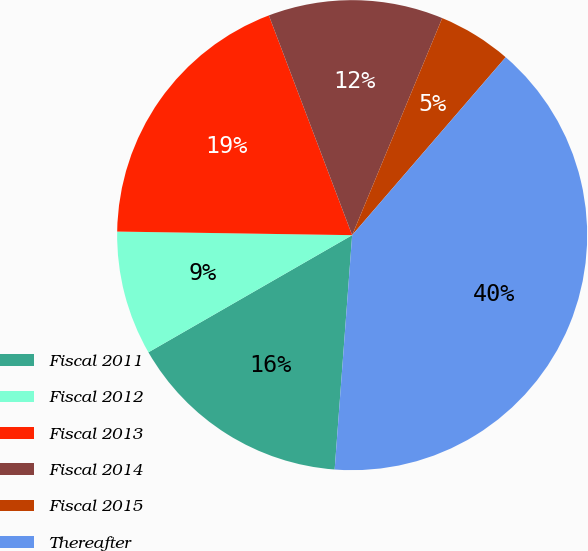Convert chart to OTSL. <chart><loc_0><loc_0><loc_500><loc_500><pie_chart><fcel>Fiscal 2011<fcel>Fiscal 2012<fcel>Fiscal 2013<fcel>Fiscal 2014<fcel>Fiscal 2015<fcel>Thereafter<nl><fcel>15.51%<fcel>8.55%<fcel>18.99%<fcel>12.03%<fcel>5.07%<fcel>39.86%<nl></chart> 